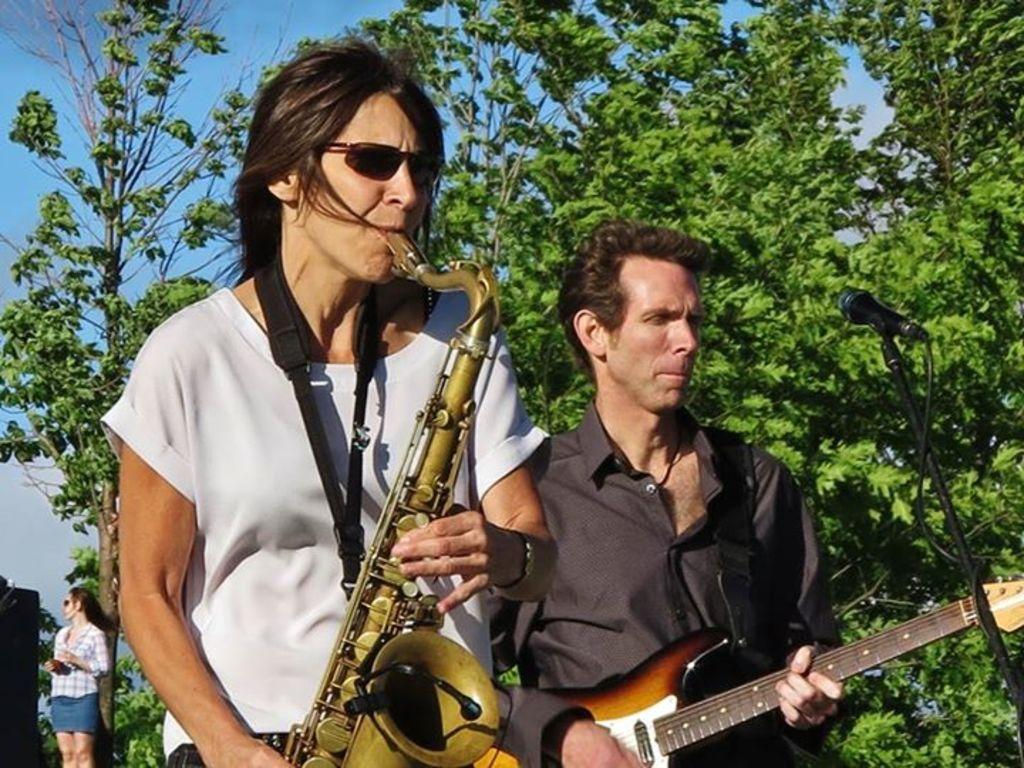Please provide a concise description of this image. This 2 persons are standing and plays a musical instruments. This is a tree. Far a woman is standing. In-front of this man there is a mic with mic holder. Sky is in blue color. 